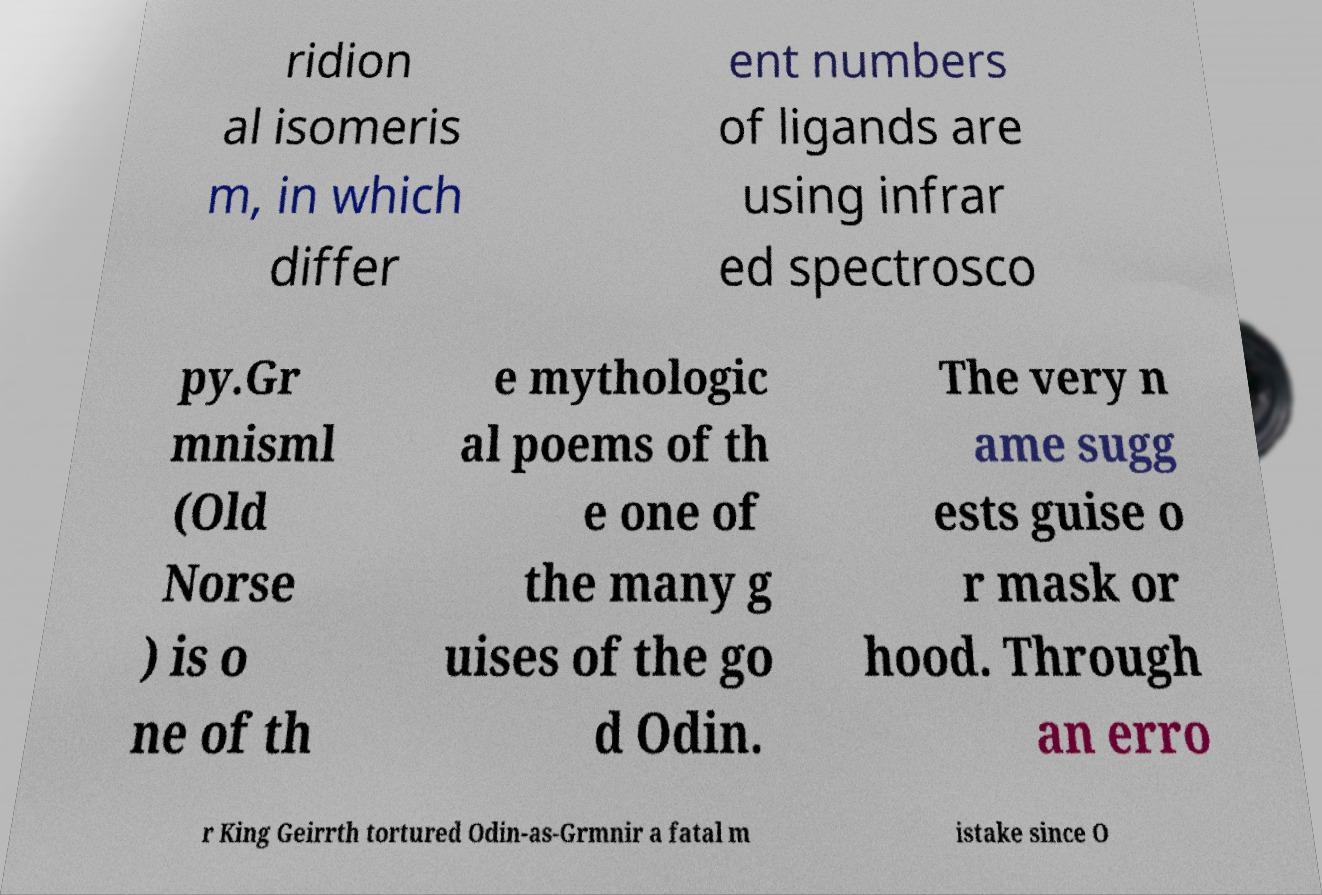Can you read and provide the text displayed in the image?This photo seems to have some interesting text. Can you extract and type it out for me? ridion al isomeris m, in which differ ent numbers of ligands are using infrar ed spectrosco py.Gr mnisml (Old Norse ) is o ne of th e mythologic al poems of th e one of the many g uises of the go d Odin. The very n ame sugg ests guise o r mask or hood. Through an erro r King Geirrth tortured Odin-as-Grmnir a fatal m istake since O 